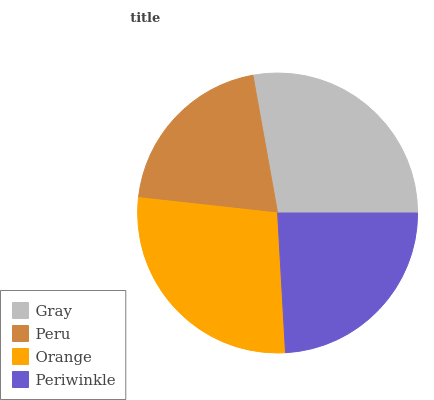Is Peru the minimum?
Answer yes or no. Yes. Is Gray the maximum?
Answer yes or no. Yes. Is Orange the minimum?
Answer yes or no. No. Is Orange the maximum?
Answer yes or no. No. Is Orange greater than Peru?
Answer yes or no. Yes. Is Peru less than Orange?
Answer yes or no. Yes. Is Peru greater than Orange?
Answer yes or no. No. Is Orange less than Peru?
Answer yes or no. No. Is Orange the high median?
Answer yes or no. Yes. Is Periwinkle the low median?
Answer yes or no. Yes. Is Periwinkle the high median?
Answer yes or no. No. Is Orange the low median?
Answer yes or no. No. 